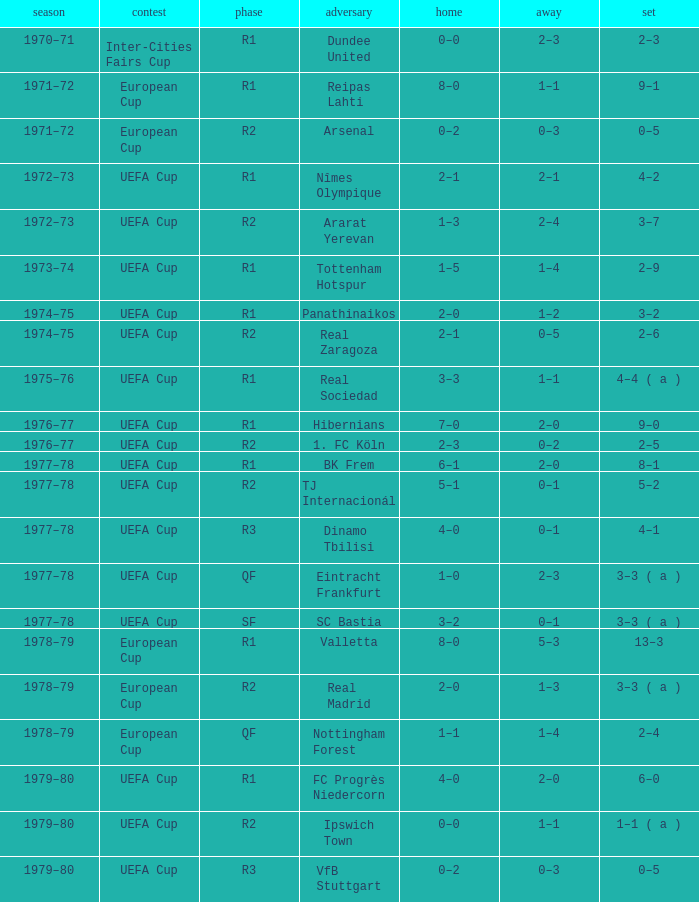Which Home has a Competition of european cup, and a Round of qf? 1–1. 